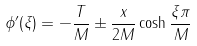Convert formula to latex. <formula><loc_0><loc_0><loc_500><loc_500>\phi ^ { \prime } ( \xi ) = - \frac { T } { M } \pm \frac { x } { 2 M } \cosh \frac { \xi \pi } { M }</formula> 